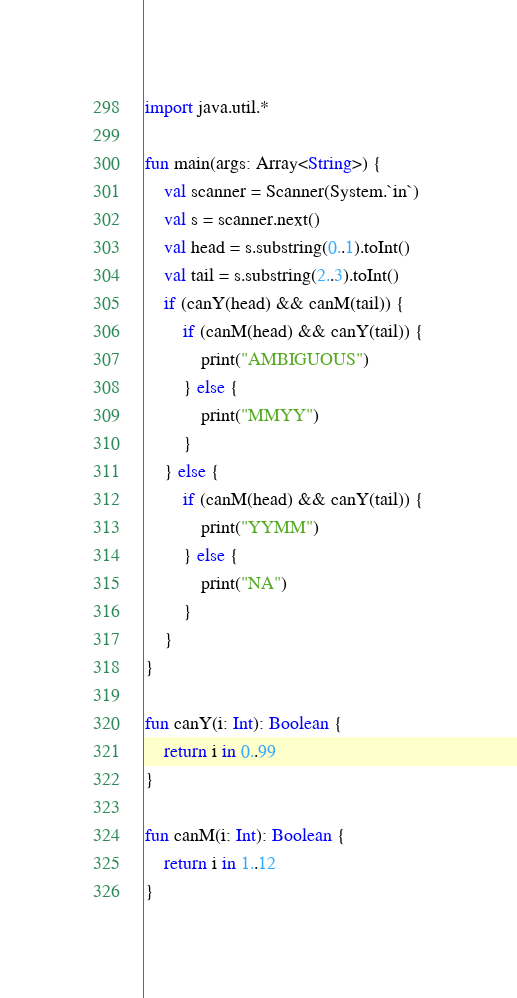Convert code to text. <code><loc_0><loc_0><loc_500><loc_500><_Kotlin_>import java.util.*

fun main(args: Array<String>) {
    val scanner = Scanner(System.`in`)
    val s = scanner.next()
    val head = s.substring(0..1).toInt()
    val tail = s.substring(2..3).toInt()
    if (canY(head) && canM(tail)) {
        if (canM(head) && canY(tail)) {
            print("AMBIGUOUS")
        } else {
            print("MMYY")
        }
    } else {
        if (canM(head) && canY(tail)) {
            print("YYMM")
        } else {
            print("NA")
        }
    }
}

fun canY(i: Int): Boolean {
    return i in 0..99
}

fun canM(i: Int): Boolean {
    return i in 1..12
}</code> 